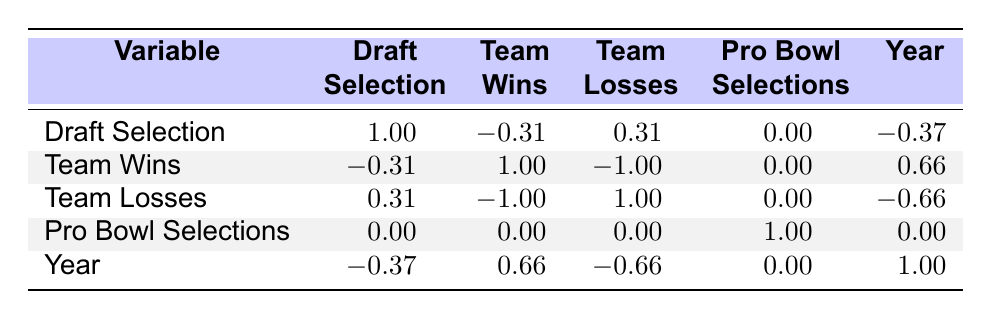What was the draft selection of Myles Jack? In the table, I can find the entry for Myles Jack under the "Player Name" column and see that his "Draft Selection" is listed as 2.
Answer: 2 What team did Josh Rosen play for in the NFL? I can locate Josh Rosen's row in the table under "Player Name" and find that the corresponding "Team" is listed as the Arizona Cardinals.
Answer: Arizona Cardinals Is there a correlation between draft selection and team wins? Referring to the correlation values in the table, I observe that the correlation between "Draft Selection" and "Team Wins" is -0.31, indicating a weak negative correlation.
Answer: Yes What has been the team performance (wins and losses) of Dorian Thompson-Robinson's team? By looking at Dorian Thompson-Robinson's entry in the table, I see that the corresponding "Team Wins" are 8 and "Team Losses" are 9.
Answer: Wins: 8, Losses: 9 Which UCLA drafted player has the highest number of team losses? By searching through the "Team Losses" column in the table, I can identify that Myles Jack's team had 13 losses, which is the highest among the listed players.
Answer: Myles Jack What is the average number of team wins for UCLA drafted players in this table? To calculate the average, I add the total wins: 3 + 3 + 7 + 8 + 5 + 9 = 35. There are 6 players, so the average is 35 / 6 = 5.83.
Answer: 5.83 Did any UCLA drafted player have a Pro Bowl selection? I can count the "Pro Bowl Selections" entries in the table and see that all values are 0, indicating that none of the listed players have been selected for the Pro Bowl.
Answer: No Which player was drafted the earliest in this dataset? I can sort the list by the "Year" column and find that Myles Jack was drafted in 2016, which is earlier than the others.
Answer: Myles Jack What is the difference in team wins between the player with the most team losses and the player with the least? Identifying Myles Jack with 3 wins and Zach Charbonnet with 9 wins, I find the difference: 9 - 3 = 6.
Answer: 6 